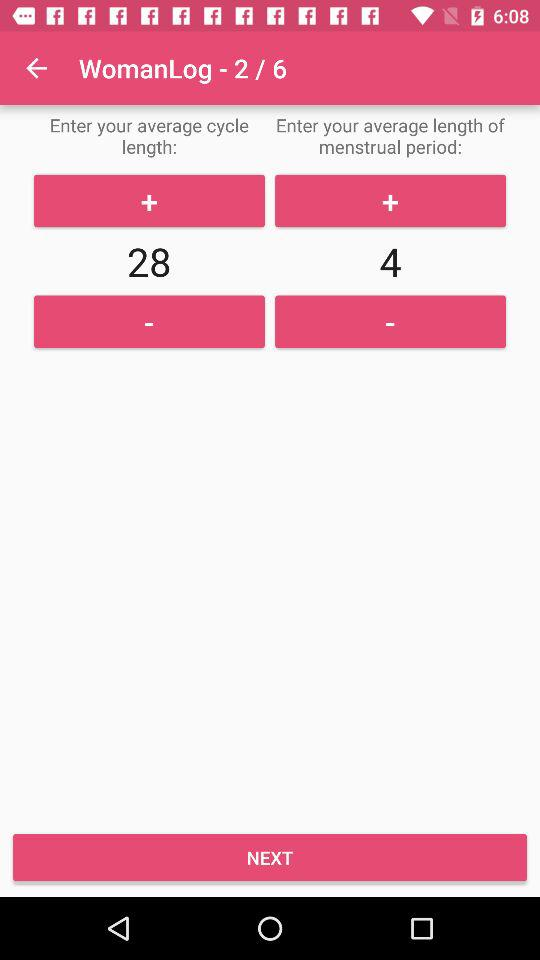What is the number of the slides in the "WomanLog"? The number of slides is 6. 